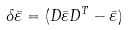<formula> <loc_0><loc_0><loc_500><loc_500>\delta \bar { \varepsilon } = ( D \bar { \varepsilon } D ^ { T } - \bar { \varepsilon } )</formula> 